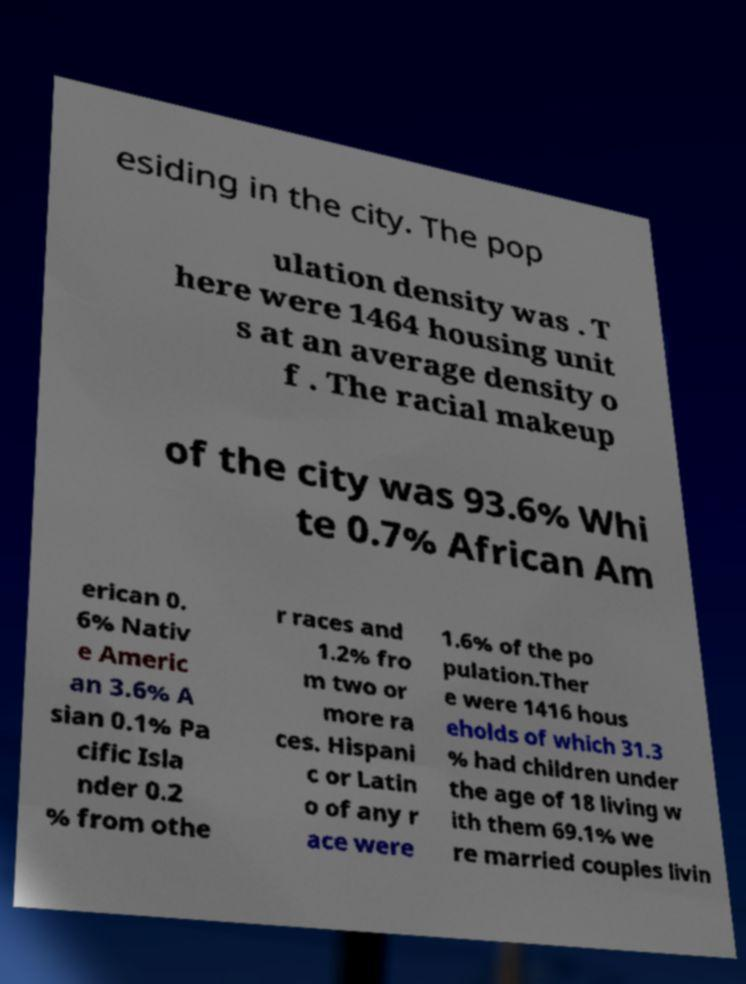Can you accurately transcribe the text from the provided image for me? esiding in the city. The pop ulation density was . T here were 1464 housing unit s at an average density o f . The racial makeup of the city was 93.6% Whi te 0.7% African Am erican 0. 6% Nativ e Americ an 3.6% A sian 0.1% Pa cific Isla nder 0.2 % from othe r races and 1.2% fro m two or more ra ces. Hispani c or Latin o of any r ace were 1.6% of the po pulation.Ther e were 1416 hous eholds of which 31.3 % had children under the age of 18 living w ith them 69.1% we re married couples livin 